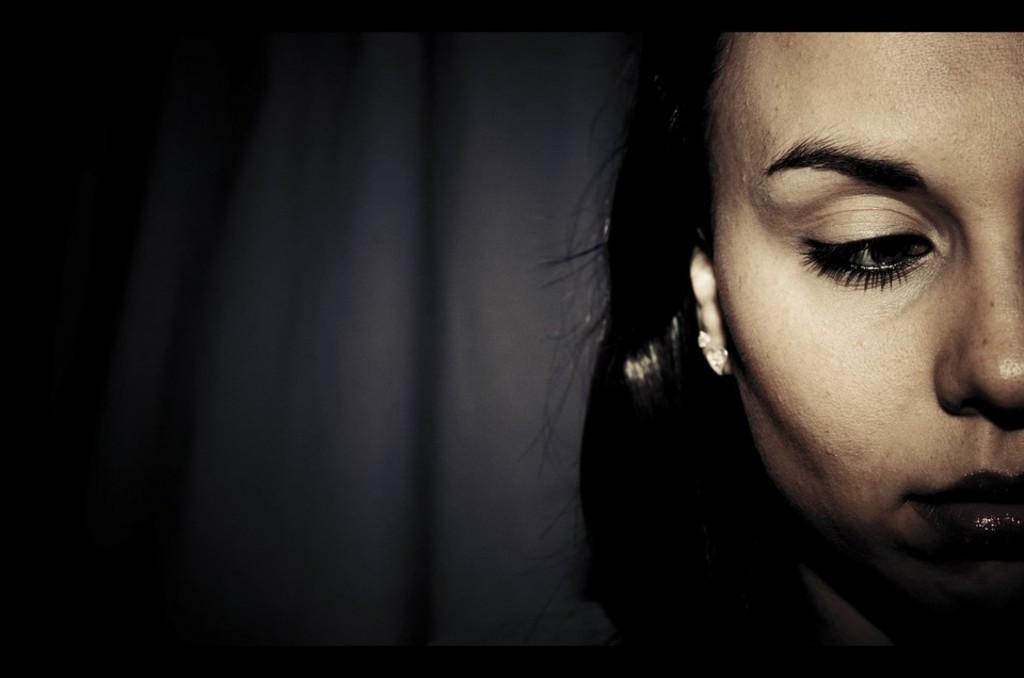Who is present on the right side of the image? There is a woman on the right side of the image. What color can be seen on the left side of the image? There is black color on the left side of the image. How many cows are present on the farm in the image? There is no farm or cows present in the image; it only features a woman and black color on the left side. 